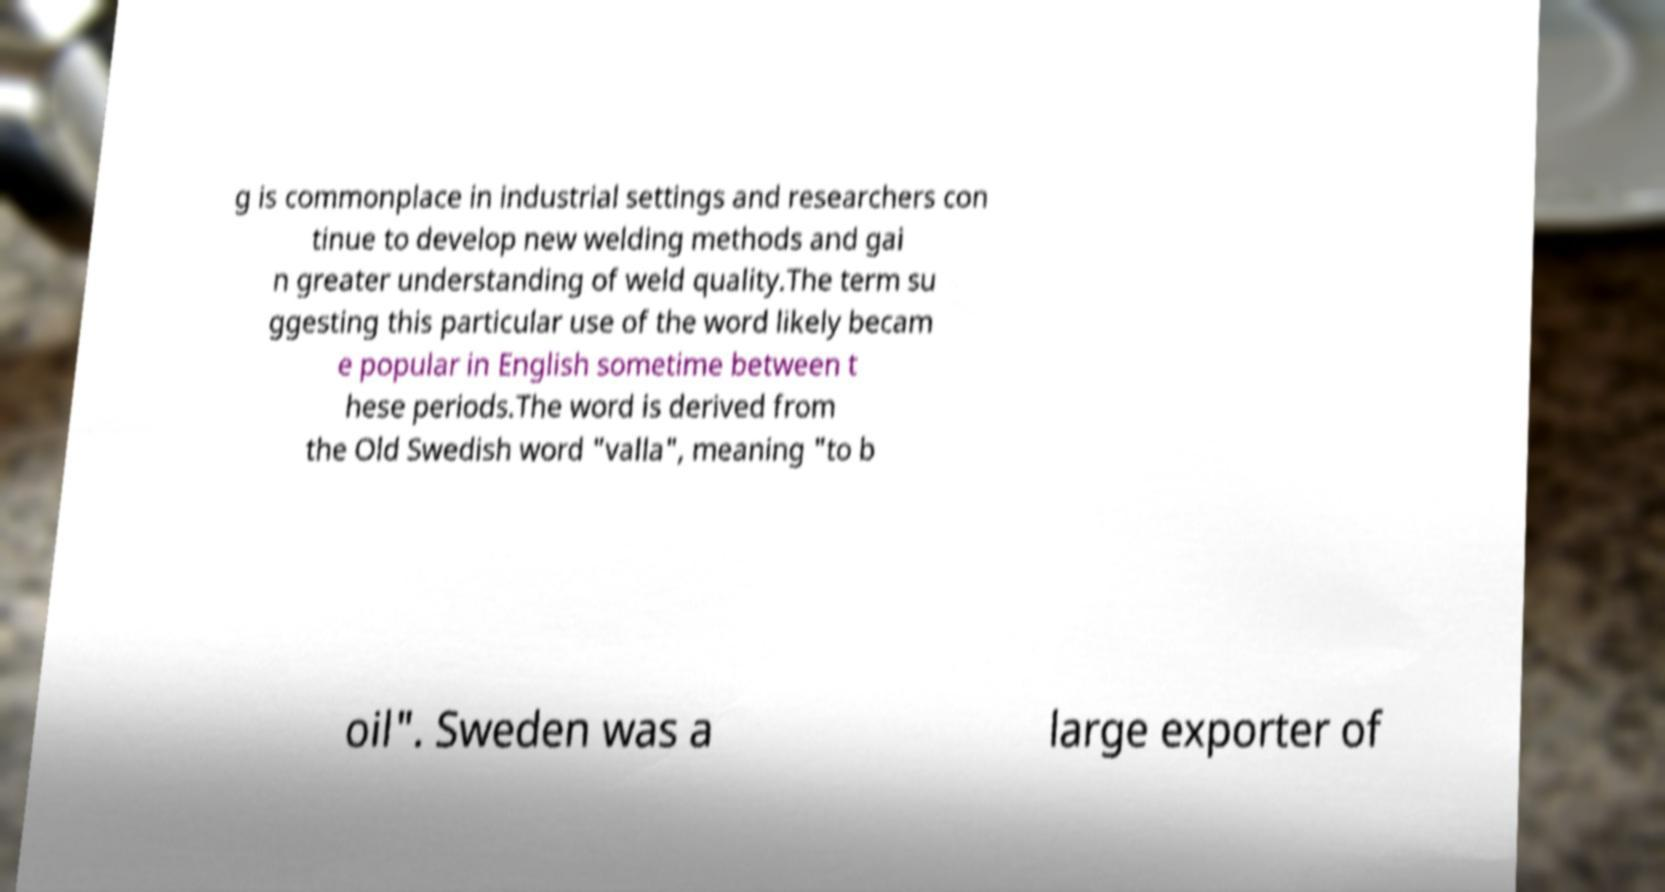I need the written content from this picture converted into text. Can you do that? g is commonplace in industrial settings and researchers con tinue to develop new welding methods and gai n greater understanding of weld quality.The term su ggesting this particular use of the word likely becam e popular in English sometime between t hese periods.The word is derived from the Old Swedish word "valla", meaning "to b oil". Sweden was a large exporter of 